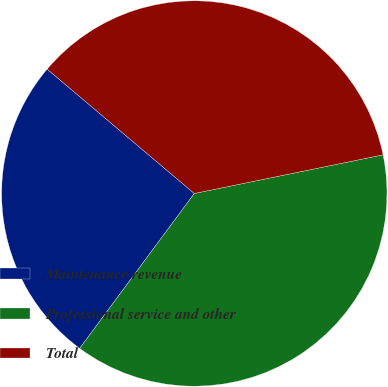Convert chart to OTSL. <chart><loc_0><loc_0><loc_500><loc_500><pie_chart><fcel>Maintenance revenue<fcel>Professional service and other<fcel>Total<nl><fcel>26.03%<fcel>38.36%<fcel>35.62%<nl></chart> 